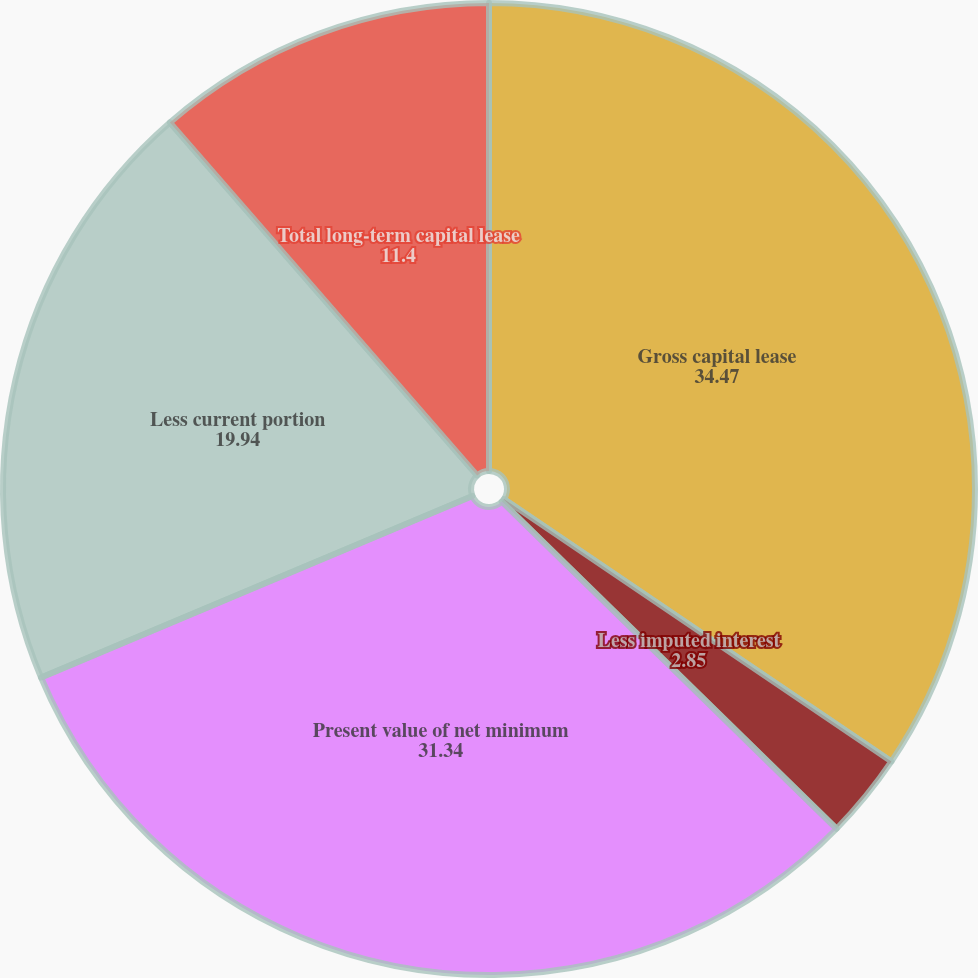Convert chart to OTSL. <chart><loc_0><loc_0><loc_500><loc_500><pie_chart><fcel>Gross capital lease<fcel>Less imputed interest<fcel>Present value of net minimum<fcel>Less current portion<fcel>Total long-term capital lease<nl><fcel>34.47%<fcel>2.85%<fcel>31.34%<fcel>19.94%<fcel>11.4%<nl></chart> 